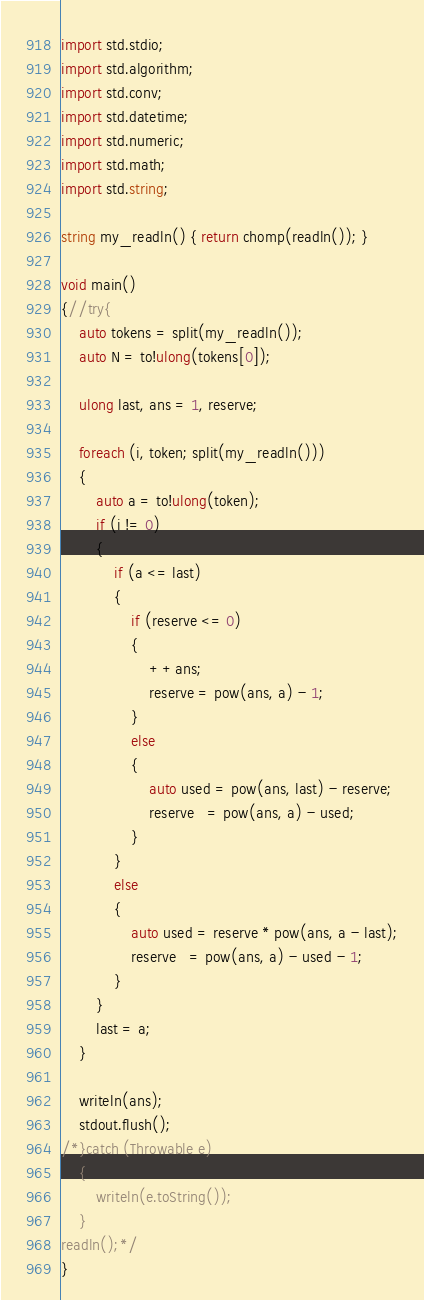<code> <loc_0><loc_0><loc_500><loc_500><_D_>import std.stdio;
import std.algorithm;
import std.conv;
import std.datetime;
import std.numeric;
import std.math;
import std.string;

string my_readln() { return chomp(readln()); }

void main()
{//try{
	auto tokens = split(my_readln());
	auto N = to!ulong(tokens[0]);

	ulong last, ans = 1, reserve;

	foreach (i, token; split(my_readln()))
	{
		auto a = to!ulong(token);
		if (i != 0)
		{
			if (a <= last)
			{
				if (reserve <= 0)
				{
					++ans;
					reserve = pow(ans, a) - 1;
				}
				else
				{
					auto used = pow(ans, last) - reserve;
					reserve   = pow(ans, a) - used;
				}
			}
			else
			{
				auto used = reserve * pow(ans, a - last);
				reserve   = pow(ans, a) - used - 1;
			}
		}
		last = a;
	}

	writeln(ans);
	stdout.flush();
/*}catch (Throwable e)
	{
		writeln(e.toString());
	}
readln();*/
}</code> 